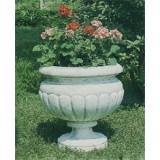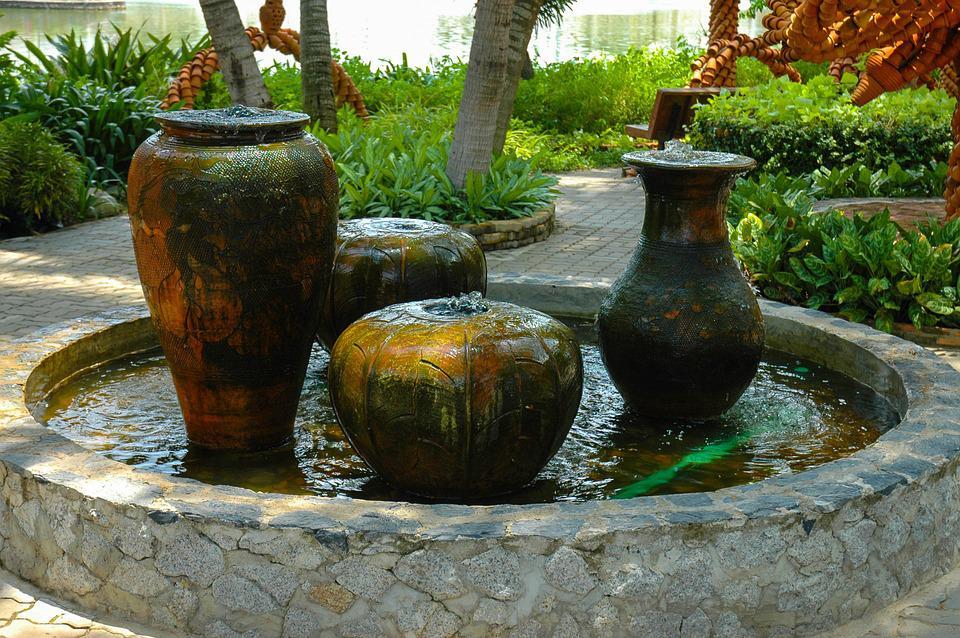The first image is the image on the left, the second image is the image on the right. For the images displayed, is the sentence "All planters are grey stone-look material and sit on square pedestal bases, and at least one planter holds a plant," factually correct? Answer yes or no. No. 